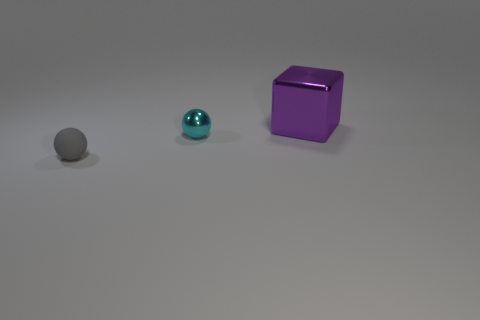What is the material of the sphere behind the rubber object?
Offer a very short reply. Metal. What number of things are either shiny objects or tiny spheres that are to the left of the tiny cyan shiny thing?
Ensure brevity in your answer.  3. What shape is the thing that is the same size as the gray sphere?
Offer a terse response. Sphere. What number of tiny shiny spheres have the same color as the big thing?
Ensure brevity in your answer.  0. Is the material of the small ball to the right of the gray matte sphere the same as the large purple thing?
Your response must be concise. Yes. What is the shape of the tiny gray rubber thing?
Your answer should be very brief. Sphere. How many gray objects are tiny metallic objects or matte spheres?
Make the answer very short. 1. What number of other objects are the same material as the small gray thing?
Make the answer very short. 0. Do the shiny object left of the large purple cube and the big metal thing have the same shape?
Ensure brevity in your answer.  No. Are there any tiny spheres?
Give a very brief answer. Yes. 